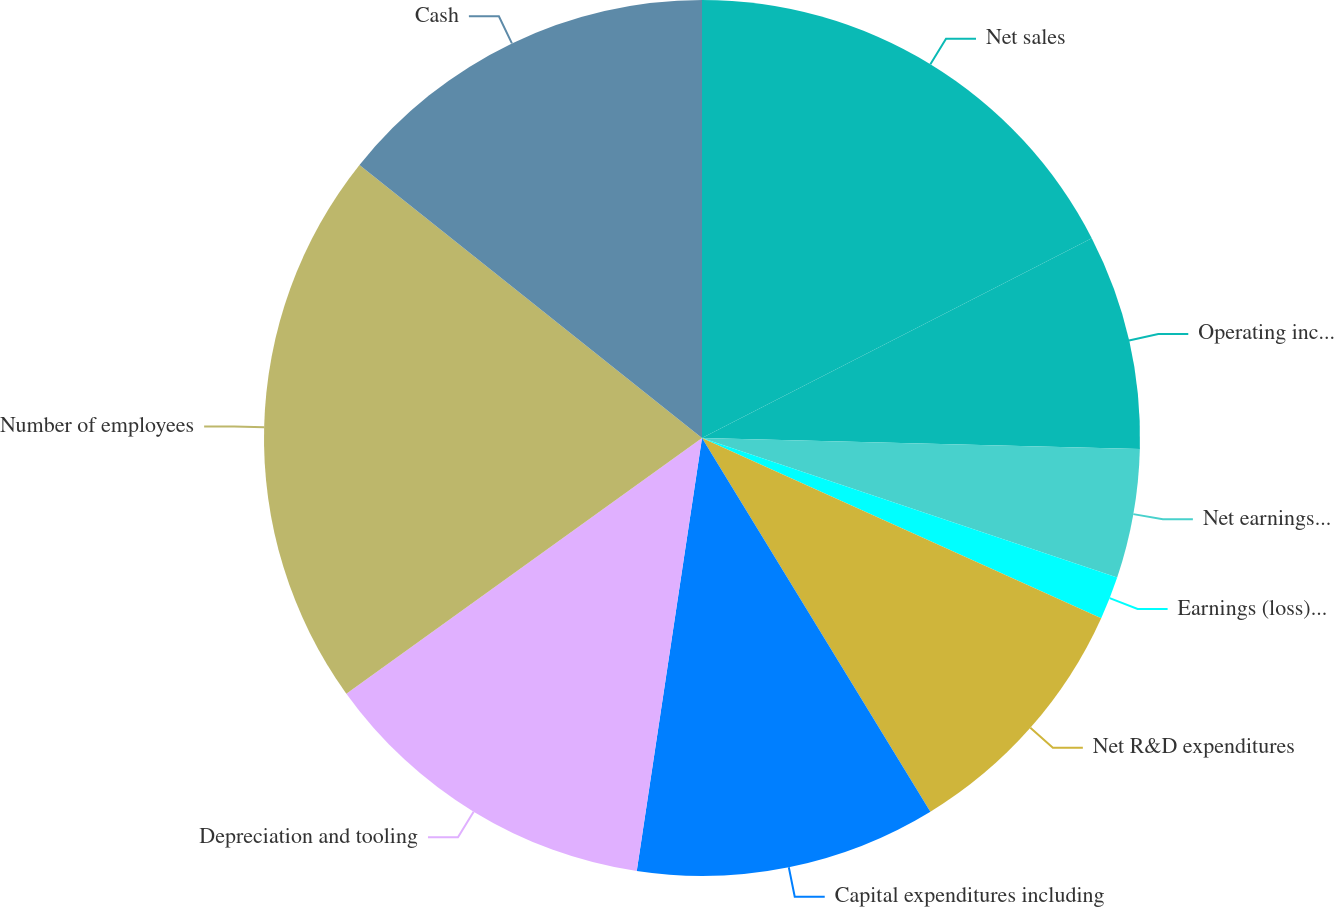Convert chart to OTSL. <chart><loc_0><loc_0><loc_500><loc_500><pie_chart><fcel>Net sales<fcel>Operating income (c)<fcel>Net earnings (loss)<fcel>Earnings (loss) per share -<fcel>Net R&D expenditures<fcel>Capital expenditures including<fcel>Depreciation and tooling<fcel>Number of employees<fcel>Cash<nl><fcel>17.46%<fcel>7.94%<fcel>4.76%<fcel>1.59%<fcel>9.52%<fcel>11.11%<fcel>12.7%<fcel>20.63%<fcel>14.29%<nl></chart> 